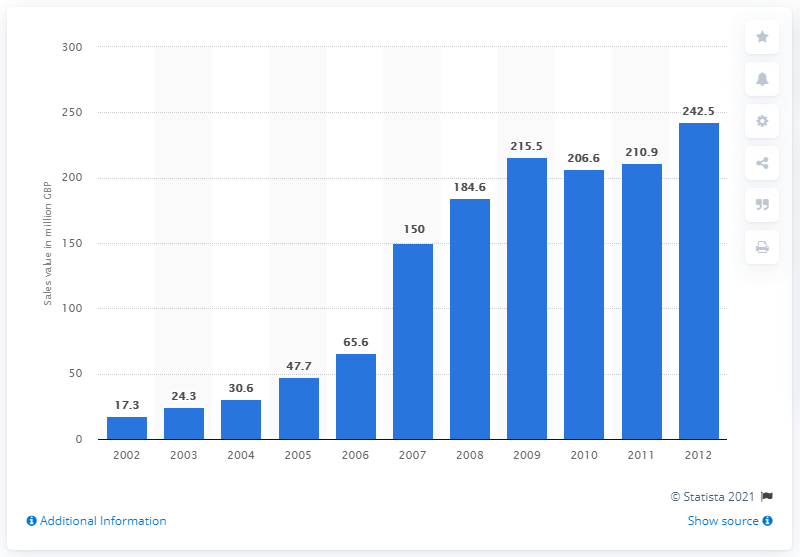Identify some key points in this picture. Fairtrade bananas generated $242.5 million in sales in 2012. 